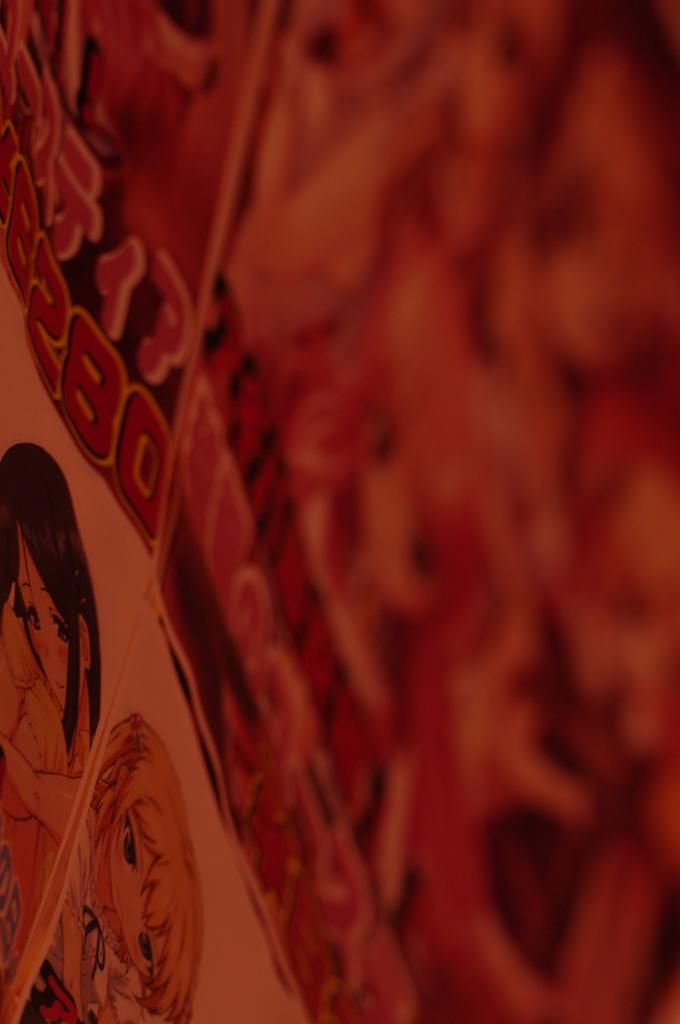What is present on the poster in the image? The poster contains images of two persons and text. Can you describe the images of the two persons on the poster? Unfortunately, the provided facts do not give a detailed description of the images of the two persons on the poster. What is the purpose of the text on the poster? The purpose of the text on the poster is not specified in the provided facts. What type of setting is the image likely taken in? The image is likely taken in a room. What type of note is being taken by one of the persons on the poster? There is no note being taken by one of the persons on the poster; the image only shows the poster itself. What type of education is being promoted by the poster? The provided facts do not specify the type of education being promoted by the poster. 